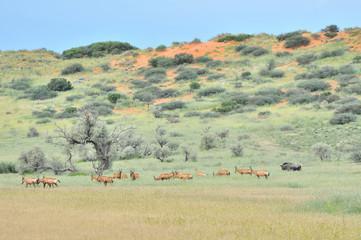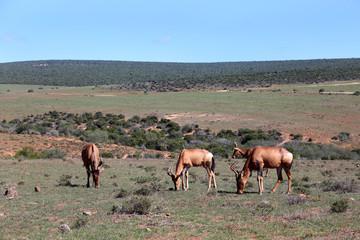The first image is the image on the left, the second image is the image on the right. For the images shown, is this caption "An image shows multiple similarly-posed gazelles with dark diagonal stripes across their bodies." true? Answer yes or no. No. 